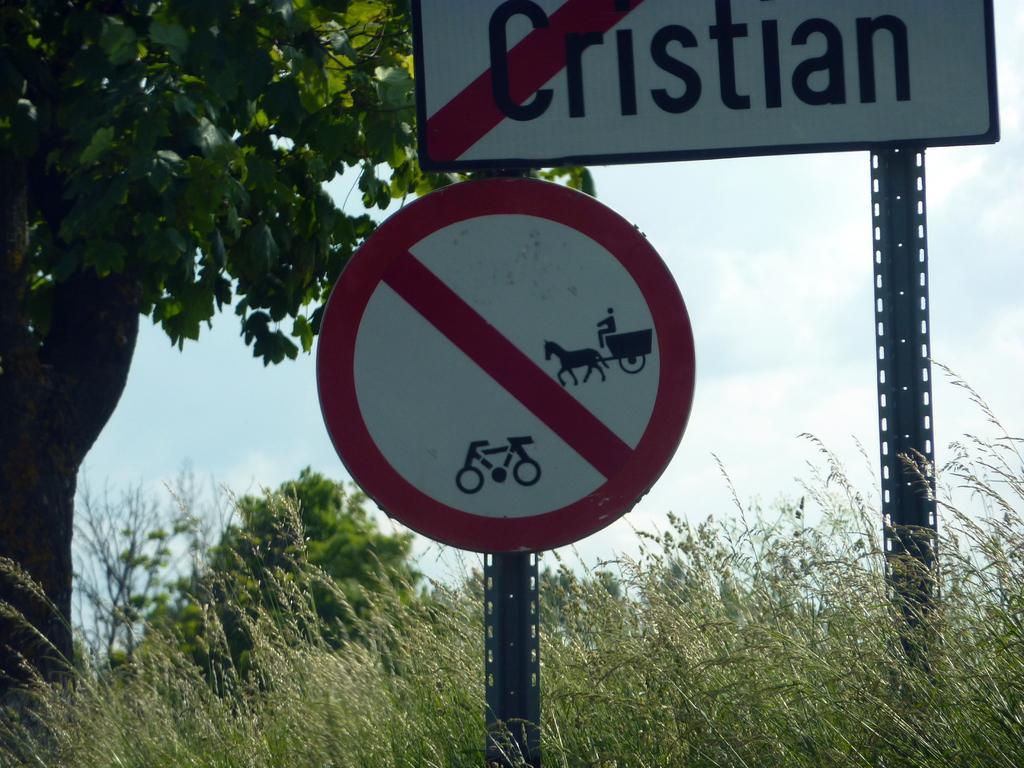Describe this image in one or two sentences. In this image there is the sky, there are clouds in the sky, there is a tree towards the top of the image, there are plants towards the bottom of the image, there are boards, there is text on the board. 